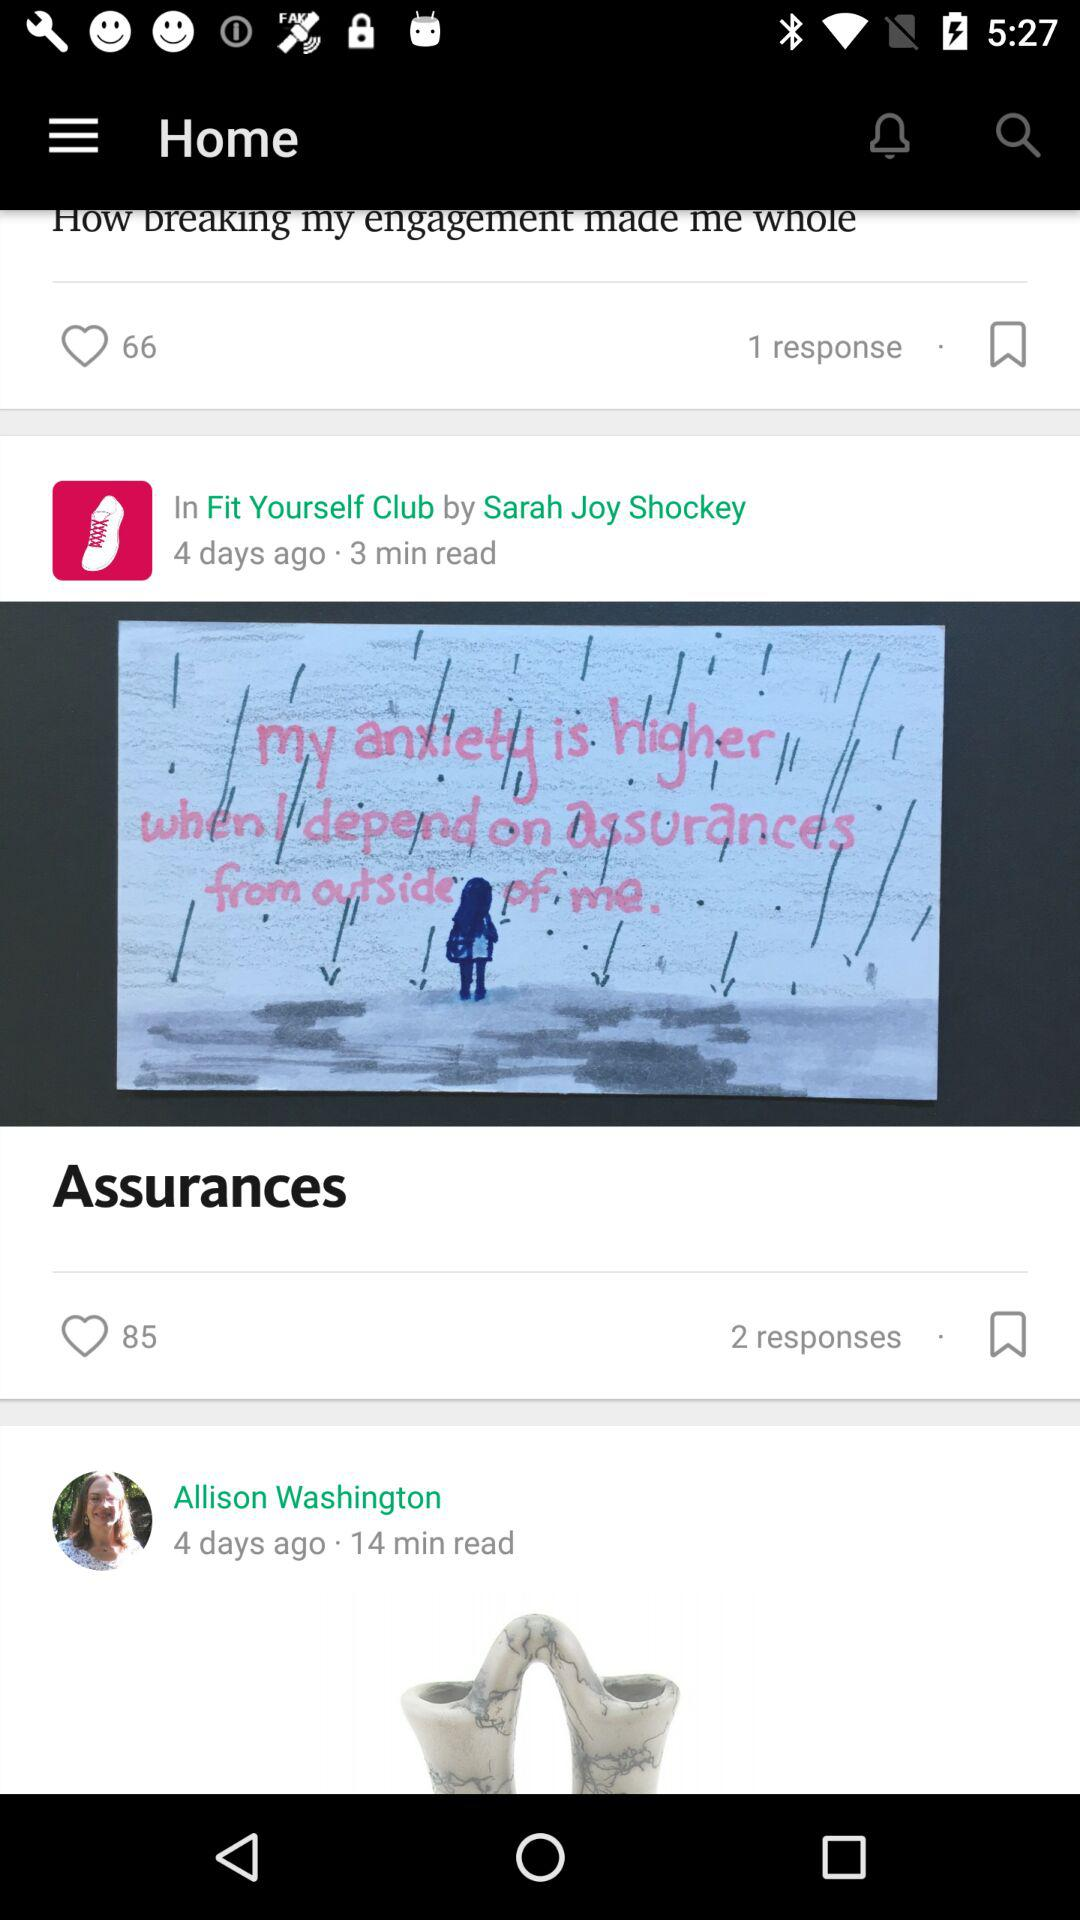Could you describe the artwork styles used in the image accompanying the 'Assurances' article? The artwork employs a minimalist style with a limited color palette, focusing on blues and whites to depict the rainy atmosphere. The figure is silhouetted, accentuating the sense of isolation. Additionally, the text is handwritten, which adds a personal, intimate touch to the message conveyed. 